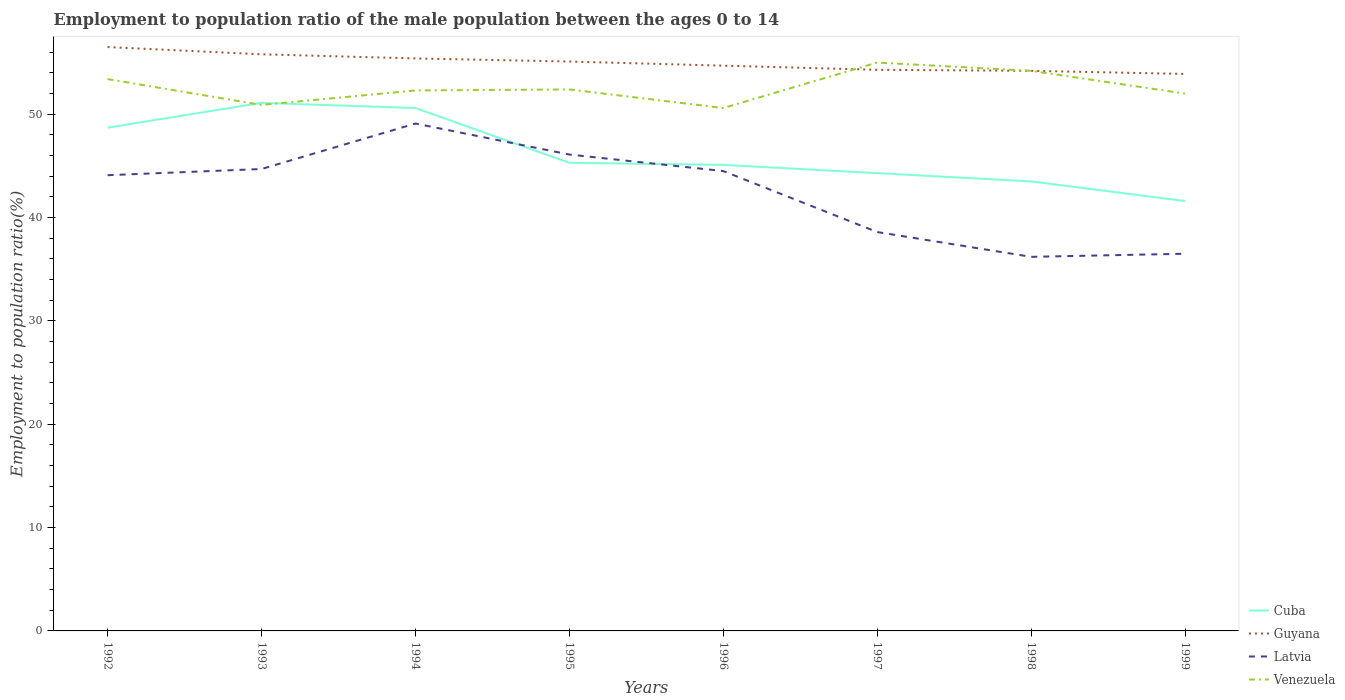How many different coloured lines are there?
Offer a terse response. 4. Is the number of lines equal to the number of legend labels?
Your response must be concise. Yes. Across all years, what is the maximum employment to population ratio in Latvia?
Provide a succinct answer. 36.2. What is the total employment to population ratio in Latvia in the graph?
Keep it short and to the point. 8.3. What is the difference between the highest and the second highest employment to population ratio in Venezuela?
Give a very brief answer. 4.4. Is the employment to population ratio in Venezuela strictly greater than the employment to population ratio in Cuba over the years?
Keep it short and to the point. No. Are the values on the major ticks of Y-axis written in scientific E-notation?
Keep it short and to the point. No. Does the graph contain any zero values?
Your response must be concise. No. How are the legend labels stacked?
Provide a short and direct response. Vertical. What is the title of the graph?
Make the answer very short. Employment to population ratio of the male population between the ages 0 to 14. What is the label or title of the X-axis?
Ensure brevity in your answer.  Years. What is the Employment to population ratio(%) of Cuba in 1992?
Offer a terse response. 48.7. What is the Employment to population ratio(%) of Guyana in 1992?
Keep it short and to the point. 56.5. What is the Employment to population ratio(%) in Latvia in 1992?
Your response must be concise. 44.1. What is the Employment to population ratio(%) in Venezuela in 1992?
Your answer should be compact. 53.4. What is the Employment to population ratio(%) in Cuba in 1993?
Provide a short and direct response. 51.1. What is the Employment to population ratio(%) of Guyana in 1993?
Your answer should be compact. 55.8. What is the Employment to population ratio(%) of Latvia in 1993?
Provide a succinct answer. 44.7. What is the Employment to population ratio(%) in Venezuela in 1993?
Make the answer very short. 50.9. What is the Employment to population ratio(%) in Cuba in 1994?
Ensure brevity in your answer.  50.6. What is the Employment to population ratio(%) in Guyana in 1994?
Ensure brevity in your answer.  55.4. What is the Employment to population ratio(%) in Latvia in 1994?
Your answer should be very brief. 49.1. What is the Employment to population ratio(%) of Venezuela in 1994?
Provide a succinct answer. 52.3. What is the Employment to population ratio(%) in Cuba in 1995?
Ensure brevity in your answer.  45.3. What is the Employment to population ratio(%) of Guyana in 1995?
Your response must be concise. 55.1. What is the Employment to population ratio(%) of Latvia in 1995?
Your answer should be very brief. 46.1. What is the Employment to population ratio(%) of Venezuela in 1995?
Make the answer very short. 52.4. What is the Employment to population ratio(%) in Cuba in 1996?
Keep it short and to the point. 45.1. What is the Employment to population ratio(%) in Guyana in 1996?
Make the answer very short. 54.7. What is the Employment to population ratio(%) of Latvia in 1996?
Keep it short and to the point. 44.5. What is the Employment to population ratio(%) of Venezuela in 1996?
Make the answer very short. 50.6. What is the Employment to population ratio(%) in Cuba in 1997?
Your answer should be very brief. 44.3. What is the Employment to population ratio(%) of Guyana in 1997?
Your answer should be compact. 54.3. What is the Employment to population ratio(%) in Latvia in 1997?
Offer a terse response. 38.6. What is the Employment to population ratio(%) of Cuba in 1998?
Make the answer very short. 43.5. What is the Employment to population ratio(%) of Guyana in 1998?
Ensure brevity in your answer.  54.2. What is the Employment to population ratio(%) in Latvia in 1998?
Offer a very short reply. 36.2. What is the Employment to population ratio(%) of Venezuela in 1998?
Make the answer very short. 54.2. What is the Employment to population ratio(%) in Cuba in 1999?
Your response must be concise. 41.6. What is the Employment to population ratio(%) in Guyana in 1999?
Your response must be concise. 53.9. What is the Employment to population ratio(%) in Latvia in 1999?
Keep it short and to the point. 36.5. Across all years, what is the maximum Employment to population ratio(%) in Cuba?
Give a very brief answer. 51.1. Across all years, what is the maximum Employment to population ratio(%) in Guyana?
Provide a succinct answer. 56.5. Across all years, what is the maximum Employment to population ratio(%) of Latvia?
Your answer should be compact. 49.1. Across all years, what is the minimum Employment to population ratio(%) in Cuba?
Provide a short and direct response. 41.6. Across all years, what is the minimum Employment to population ratio(%) of Guyana?
Your response must be concise. 53.9. Across all years, what is the minimum Employment to population ratio(%) of Latvia?
Your answer should be compact. 36.2. Across all years, what is the minimum Employment to population ratio(%) of Venezuela?
Ensure brevity in your answer.  50.6. What is the total Employment to population ratio(%) in Cuba in the graph?
Offer a very short reply. 370.2. What is the total Employment to population ratio(%) in Guyana in the graph?
Make the answer very short. 439.9. What is the total Employment to population ratio(%) in Latvia in the graph?
Provide a succinct answer. 339.8. What is the total Employment to population ratio(%) of Venezuela in the graph?
Your response must be concise. 420.8. What is the difference between the Employment to population ratio(%) of Latvia in 1992 and that in 1993?
Give a very brief answer. -0.6. What is the difference between the Employment to population ratio(%) of Cuba in 1992 and that in 1994?
Give a very brief answer. -1.9. What is the difference between the Employment to population ratio(%) in Guyana in 1992 and that in 1994?
Your answer should be compact. 1.1. What is the difference between the Employment to population ratio(%) in Latvia in 1992 and that in 1994?
Make the answer very short. -5. What is the difference between the Employment to population ratio(%) of Latvia in 1992 and that in 1995?
Your answer should be compact. -2. What is the difference between the Employment to population ratio(%) of Venezuela in 1992 and that in 1995?
Make the answer very short. 1. What is the difference between the Employment to population ratio(%) of Cuba in 1992 and that in 1996?
Your answer should be very brief. 3.6. What is the difference between the Employment to population ratio(%) of Cuba in 1992 and that in 1998?
Provide a short and direct response. 5.2. What is the difference between the Employment to population ratio(%) in Guyana in 1992 and that in 1998?
Offer a terse response. 2.3. What is the difference between the Employment to population ratio(%) in Venezuela in 1992 and that in 1998?
Ensure brevity in your answer.  -0.8. What is the difference between the Employment to population ratio(%) in Cuba in 1992 and that in 1999?
Your answer should be compact. 7.1. What is the difference between the Employment to population ratio(%) in Venezuela in 1992 and that in 1999?
Provide a short and direct response. 1.4. What is the difference between the Employment to population ratio(%) of Cuba in 1993 and that in 1994?
Your answer should be very brief. 0.5. What is the difference between the Employment to population ratio(%) of Cuba in 1993 and that in 1995?
Your answer should be compact. 5.8. What is the difference between the Employment to population ratio(%) in Latvia in 1993 and that in 1995?
Your answer should be very brief. -1.4. What is the difference between the Employment to population ratio(%) in Venezuela in 1993 and that in 1995?
Make the answer very short. -1.5. What is the difference between the Employment to population ratio(%) of Cuba in 1993 and that in 1996?
Give a very brief answer. 6. What is the difference between the Employment to population ratio(%) in Latvia in 1993 and that in 1996?
Provide a succinct answer. 0.2. What is the difference between the Employment to population ratio(%) of Cuba in 1993 and that in 1997?
Provide a succinct answer. 6.8. What is the difference between the Employment to population ratio(%) in Guyana in 1993 and that in 1998?
Ensure brevity in your answer.  1.6. What is the difference between the Employment to population ratio(%) of Latvia in 1993 and that in 1998?
Make the answer very short. 8.5. What is the difference between the Employment to population ratio(%) of Venezuela in 1993 and that in 1998?
Offer a terse response. -3.3. What is the difference between the Employment to population ratio(%) of Latvia in 1993 and that in 1999?
Offer a very short reply. 8.2. What is the difference between the Employment to population ratio(%) in Venezuela in 1993 and that in 1999?
Your response must be concise. -1.1. What is the difference between the Employment to population ratio(%) in Cuba in 1994 and that in 1995?
Offer a terse response. 5.3. What is the difference between the Employment to population ratio(%) of Guyana in 1994 and that in 1996?
Offer a very short reply. 0.7. What is the difference between the Employment to population ratio(%) in Venezuela in 1994 and that in 1996?
Provide a short and direct response. 1.7. What is the difference between the Employment to population ratio(%) of Latvia in 1994 and that in 1997?
Make the answer very short. 10.5. What is the difference between the Employment to population ratio(%) in Venezuela in 1994 and that in 1997?
Make the answer very short. -2.7. What is the difference between the Employment to population ratio(%) in Cuba in 1994 and that in 1999?
Offer a very short reply. 9. What is the difference between the Employment to population ratio(%) of Latvia in 1994 and that in 1999?
Your answer should be compact. 12.6. What is the difference between the Employment to population ratio(%) of Cuba in 1995 and that in 1996?
Offer a very short reply. 0.2. What is the difference between the Employment to population ratio(%) of Latvia in 1995 and that in 1996?
Your answer should be compact. 1.6. What is the difference between the Employment to population ratio(%) in Cuba in 1995 and that in 1997?
Your response must be concise. 1. What is the difference between the Employment to population ratio(%) in Latvia in 1995 and that in 1997?
Provide a short and direct response. 7.5. What is the difference between the Employment to population ratio(%) in Venezuela in 1995 and that in 1998?
Provide a short and direct response. -1.8. What is the difference between the Employment to population ratio(%) in Cuba in 1996 and that in 1997?
Ensure brevity in your answer.  0.8. What is the difference between the Employment to population ratio(%) of Venezuela in 1996 and that in 1997?
Your response must be concise. -4.4. What is the difference between the Employment to population ratio(%) in Cuba in 1996 and that in 1998?
Provide a succinct answer. 1.6. What is the difference between the Employment to population ratio(%) of Latvia in 1996 and that in 1998?
Ensure brevity in your answer.  8.3. What is the difference between the Employment to population ratio(%) in Guyana in 1996 and that in 1999?
Keep it short and to the point. 0.8. What is the difference between the Employment to population ratio(%) of Latvia in 1996 and that in 1999?
Provide a short and direct response. 8. What is the difference between the Employment to population ratio(%) in Venezuela in 1996 and that in 1999?
Ensure brevity in your answer.  -1.4. What is the difference between the Employment to population ratio(%) of Cuba in 1997 and that in 1998?
Give a very brief answer. 0.8. What is the difference between the Employment to population ratio(%) in Guyana in 1997 and that in 1998?
Ensure brevity in your answer.  0.1. What is the difference between the Employment to population ratio(%) of Venezuela in 1997 and that in 1998?
Provide a succinct answer. 0.8. What is the difference between the Employment to population ratio(%) in Latvia in 1997 and that in 1999?
Offer a very short reply. 2.1. What is the difference between the Employment to population ratio(%) of Guyana in 1998 and that in 1999?
Keep it short and to the point. 0.3. What is the difference between the Employment to population ratio(%) in Latvia in 1998 and that in 1999?
Offer a very short reply. -0.3. What is the difference between the Employment to population ratio(%) of Venezuela in 1998 and that in 1999?
Ensure brevity in your answer.  2.2. What is the difference between the Employment to population ratio(%) in Cuba in 1992 and the Employment to population ratio(%) in Venezuela in 1993?
Your answer should be compact. -2.2. What is the difference between the Employment to population ratio(%) in Guyana in 1992 and the Employment to population ratio(%) in Latvia in 1993?
Your answer should be very brief. 11.8. What is the difference between the Employment to population ratio(%) of Guyana in 1992 and the Employment to population ratio(%) of Venezuela in 1993?
Provide a succinct answer. 5.6. What is the difference between the Employment to population ratio(%) in Latvia in 1992 and the Employment to population ratio(%) in Venezuela in 1993?
Give a very brief answer. -6.8. What is the difference between the Employment to population ratio(%) of Cuba in 1992 and the Employment to population ratio(%) of Guyana in 1994?
Your answer should be compact. -6.7. What is the difference between the Employment to population ratio(%) in Latvia in 1992 and the Employment to population ratio(%) in Venezuela in 1994?
Ensure brevity in your answer.  -8.2. What is the difference between the Employment to population ratio(%) in Cuba in 1992 and the Employment to population ratio(%) in Guyana in 1995?
Offer a terse response. -6.4. What is the difference between the Employment to population ratio(%) in Cuba in 1992 and the Employment to population ratio(%) in Latvia in 1995?
Offer a very short reply. 2.6. What is the difference between the Employment to population ratio(%) in Cuba in 1992 and the Employment to population ratio(%) in Venezuela in 1995?
Your answer should be compact. -3.7. What is the difference between the Employment to population ratio(%) in Guyana in 1992 and the Employment to population ratio(%) in Latvia in 1995?
Keep it short and to the point. 10.4. What is the difference between the Employment to population ratio(%) in Guyana in 1992 and the Employment to population ratio(%) in Venezuela in 1995?
Provide a short and direct response. 4.1. What is the difference between the Employment to population ratio(%) in Latvia in 1992 and the Employment to population ratio(%) in Venezuela in 1995?
Provide a short and direct response. -8.3. What is the difference between the Employment to population ratio(%) in Cuba in 1992 and the Employment to population ratio(%) in Venezuela in 1996?
Ensure brevity in your answer.  -1.9. What is the difference between the Employment to population ratio(%) of Guyana in 1992 and the Employment to population ratio(%) of Latvia in 1996?
Your answer should be compact. 12. What is the difference between the Employment to population ratio(%) of Guyana in 1992 and the Employment to population ratio(%) of Venezuela in 1996?
Provide a succinct answer. 5.9. What is the difference between the Employment to population ratio(%) of Latvia in 1992 and the Employment to population ratio(%) of Venezuela in 1996?
Offer a terse response. -6.5. What is the difference between the Employment to population ratio(%) of Cuba in 1992 and the Employment to population ratio(%) of Latvia in 1997?
Provide a succinct answer. 10.1. What is the difference between the Employment to population ratio(%) in Cuba in 1992 and the Employment to population ratio(%) in Venezuela in 1997?
Offer a very short reply. -6.3. What is the difference between the Employment to population ratio(%) of Latvia in 1992 and the Employment to population ratio(%) of Venezuela in 1997?
Your answer should be compact. -10.9. What is the difference between the Employment to population ratio(%) of Cuba in 1992 and the Employment to population ratio(%) of Guyana in 1998?
Make the answer very short. -5.5. What is the difference between the Employment to population ratio(%) of Guyana in 1992 and the Employment to population ratio(%) of Latvia in 1998?
Provide a succinct answer. 20.3. What is the difference between the Employment to population ratio(%) of Guyana in 1992 and the Employment to population ratio(%) of Venezuela in 1998?
Offer a very short reply. 2.3. What is the difference between the Employment to population ratio(%) in Latvia in 1992 and the Employment to population ratio(%) in Venezuela in 1998?
Ensure brevity in your answer.  -10.1. What is the difference between the Employment to population ratio(%) of Cuba in 1992 and the Employment to population ratio(%) of Guyana in 1999?
Your answer should be compact. -5.2. What is the difference between the Employment to population ratio(%) in Cuba in 1992 and the Employment to population ratio(%) in Latvia in 1999?
Ensure brevity in your answer.  12.2. What is the difference between the Employment to population ratio(%) of Cuba in 1992 and the Employment to population ratio(%) of Venezuela in 1999?
Provide a short and direct response. -3.3. What is the difference between the Employment to population ratio(%) in Latvia in 1992 and the Employment to population ratio(%) in Venezuela in 1999?
Make the answer very short. -7.9. What is the difference between the Employment to population ratio(%) in Guyana in 1993 and the Employment to population ratio(%) in Latvia in 1994?
Your answer should be compact. 6.7. What is the difference between the Employment to population ratio(%) in Guyana in 1993 and the Employment to population ratio(%) in Venezuela in 1994?
Provide a short and direct response. 3.5. What is the difference between the Employment to population ratio(%) of Cuba in 1993 and the Employment to population ratio(%) of Guyana in 1995?
Keep it short and to the point. -4. What is the difference between the Employment to population ratio(%) of Cuba in 1993 and the Employment to population ratio(%) of Latvia in 1995?
Provide a short and direct response. 5. What is the difference between the Employment to population ratio(%) of Guyana in 1993 and the Employment to population ratio(%) of Latvia in 1995?
Provide a succinct answer. 9.7. What is the difference between the Employment to population ratio(%) in Latvia in 1993 and the Employment to population ratio(%) in Venezuela in 1995?
Ensure brevity in your answer.  -7.7. What is the difference between the Employment to population ratio(%) of Cuba in 1993 and the Employment to population ratio(%) of Venezuela in 1996?
Your answer should be compact. 0.5. What is the difference between the Employment to population ratio(%) in Guyana in 1993 and the Employment to population ratio(%) in Latvia in 1996?
Offer a terse response. 11.3. What is the difference between the Employment to population ratio(%) in Guyana in 1993 and the Employment to population ratio(%) in Venezuela in 1996?
Make the answer very short. 5.2. What is the difference between the Employment to population ratio(%) of Cuba in 1993 and the Employment to population ratio(%) of Guyana in 1997?
Ensure brevity in your answer.  -3.2. What is the difference between the Employment to population ratio(%) in Cuba in 1993 and the Employment to population ratio(%) in Latvia in 1997?
Your response must be concise. 12.5. What is the difference between the Employment to population ratio(%) in Latvia in 1993 and the Employment to population ratio(%) in Venezuela in 1997?
Your answer should be very brief. -10.3. What is the difference between the Employment to population ratio(%) in Guyana in 1993 and the Employment to population ratio(%) in Latvia in 1998?
Provide a short and direct response. 19.6. What is the difference between the Employment to population ratio(%) of Latvia in 1993 and the Employment to population ratio(%) of Venezuela in 1998?
Provide a short and direct response. -9.5. What is the difference between the Employment to population ratio(%) of Cuba in 1993 and the Employment to population ratio(%) of Guyana in 1999?
Your answer should be compact. -2.8. What is the difference between the Employment to population ratio(%) in Guyana in 1993 and the Employment to population ratio(%) in Latvia in 1999?
Provide a short and direct response. 19.3. What is the difference between the Employment to population ratio(%) of Guyana in 1993 and the Employment to population ratio(%) of Venezuela in 1999?
Keep it short and to the point. 3.8. What is the difference between the Employment to population ratio(%) of Latvia in 1993 and the Employment to population ratio(%) of Venezuela in 1999?
Give a very brief answer. -7.3. What is the difference between the Employment to population ratio(%) in Cuba in 1994 and the Employment to population ratio(%) in Guyana in 1995?
Provide a short and direct response. -4.5. What is the difference between the Employment to population ratio(%) of Cuba in 1994 and the Employment to population ratio(%) of Latvia in 1995?
Provide a short and direct response. 4.5. What is the difference between the Employment to population ratio(%) in Cuba in 1994 and the Employment to population ratio(%) in Venezuela in 1995?
Ensure brevity in your answer.  -1.8. What is the difference between the Employment to population ratio(%) of Guyana in 1994 and the Employment to population ratio(%) of Venezuela in 1995?
Provide a succinct answer. 3. What is the difference between the Employment to population ratio(%) in Guyana in 1994 and the Employment to population ratio(%) in Latvia in 1996?
Offer a very short reply. 10.9. What is the difference between the Employment to population ratio(%) of Cuba in 1994 and the Employment to population ratio(%) of Latvia in 1997?
Give a very brief answer. 12. What is the difference between the Employment to population ratio(%) in Guyana in 1994 and the Employment to population ratio(%) in Latvia in 1997?
Give a very brief answer. 16.8. What is the difference between the Employment to population ratio(%) of Latvia in 1994 and the Employment to population ratio(%) of Venezuela in 1997?
Offer a very short reply. -5.9. What is the difference between the Employment to population ratio(%) of Cuba in 1994 and the Employment to population ratio(%) of Guyana in 1998?
Your answer should be compact. -3.6. What is the difference between the Employment to population ratio(%) of Cuba in 1994 and the Employment to population ratio(%) of Venezuela in 1998?
Provide a short and direct response. -3.6. What is the difference between the Employment to population ratio(%) in Guyana in 1994 and the Employment to population ratio(%) in Venezuela in 1998?
Offer a terse response. 1.2. What is the difference between the Employment to population ratio(%) in Cuba in 1994 and the Employment to population ratio(%) in Latvia in 1999?
Your answer should be very brief. 14.1. What is the difference between the Employment to population ratio(%) in Latvia in 1994 and the Employment to population ratio(%) in Venezuela in 1999?
Your answer should be compact. -2.9. What is the difference between the Employment to population ratio(%) of Guyana in 1995 and the Employment to population ratio(%) of Latvia in 1997?
Make the answer very short. 16.5. What is the difference between the Employment to population ratio(%) in Cuba in 1995 and the Employment to population ratio(%) in Latvia in 1998?
Ensure brevity in your answer.  9.1. What is the difference between the Employment to population ratio(%) of Guyana in 1995 and the Employment to population ratio(%) of Latvia in 1998?
Offer a terse response. 18.9. What is the difference between the Employment to population ratio(%) of Guyana in 1995 and the Employment to population ratio(%) of Venezuela in 1998?
Your response must be concise. 0.9. What is the difference between the Employment to population ratio(%) in Cuba in 1995 and the Employment to population ratio(%) in Latvia in 1999?
Give a very brief answer. 8.8. What is the difference between the Employment to population ratio(%) of Guyana in 1995 and the Employment to population ratio(%) of Latvia in 1999?
Your answer should be compact. 18.6. What is the difference between the Employment to population ratio(%) in Latvia in 1995 and the Employment to population ratio(%) in Venezuela in 1999?
Offer a terse response. -5.9. What is the difference between the Employment to population ratio(%) in Cuba in 1996 and the Employment to population ratio(%) in Guyana in 1997?
Your response must be concise. -9.2. What is the difference between the Employment to population ratio(%) in Cuba in 1996 and the Employment to population ratio(%) in Venezuela in 1997?
Ensure brevity in your answer.  -9.9. What is the difference between the Employment to population ratio(%) in Latvia in 1996 and the Employment to population ratio(%) in Venezuela in 1997?
Your answer should be very brief. -10.5. What is the difference between the Employment to population ratio(%) of Cuba in 1996 and the Employment to population ratio(%) of Guyana in 1998?
Offer a terse response. -9.1. What is the difference between the Employment to population ratio(%) in Cuba in 1996 and the Employment to population ratio(%) in Venezuela in 1998?
Offer a terse response. -9.1. What is the difference between the Employment to population ratio(%) of Guyana in 1996 and the Employment to population ratio(%) of Latvia in 1998?
Keep it short and to the point. 18.5. What is the difference between the Employment to population ratio(%) in Latvia in 1996 and the Employment to population ratio(%) in Venezuela in 1998?
Offer a very short reply. -9.7. What is the difference between the Employment to population ratio(%) of Cuba in 1996 and the Employment to population ratio(%) of Guyana in 1999?
Your answer should be compact. -8.8. What is the difference between the Employment to population ratio(%) of Cuba in 1996 and the Employment to population ratio(%) of Venezuela in 1999?
Give a very brief answer. -6.9. What is the difference between the Employment to population ratio(%) of Latvia in 1996 and the Employment to population ratio(%) of Venezuela in 1999?
Give a very brief answer. -7.5. What is the difference between the Employment to population ratio(%) in Cuba in 1997 and the Employment to population ratio(%) in Guyana in 1998?
Your answer should be compact. -9.9. What is the difference between the Employment to population ratio(%) of Cuba in 1997 and the Employment to population ratio(%) of Latvia in 1998?
Your answer should be very brief. 8.1. What is the difference between the Employment to population ratio(%) of Guyana in 1997 and the Employment to population ratio(%) of Venezuela in 1998?
Your answer should be compact. 0.1. What is the difference between the Employment to population ratio(%) of Latvia in 1997 and the Employment to population ratio(%) of Venezuela in 1998?
Provide a short and direct response. -15.6. What is the difference between the Employment to population ratio(%) of Cuba in 1997 and the Employment to population ratio(%) of Venezuela in 1999?
Make the answer very short. -7.7. What is the difference between the Employment to population ratio(%) in Guyana in 1997 and the Employment to population ratio(%) in Latvia in 1999?
Your answer should be compact. 17.8. What is the difference between the Employment to population ratio(%) of Guyana in 1998 and the Employment to population ratio(%) of Venezuela in 1999?
Your response must be concise. 2.2. What is the difference between the Employment to population ratio(%) in Latvia in 1998 and the Employment to population ratio(%) in Venezuela in 1999?
Your answer should be compact. -15.8. What is the average Employment to population ratio(%) of Cuba per year?
Provide a short and direct response. 46.27. What is the average Employment to population ratio(%) of Guyana per year?
Make the answer very short. 54.99. What is the average Employment to population ratio(%) in Latvia per year?
Make the answer very short. 42.48. What is the average Employment to population ratio(%) of Venezuela per year?
Keep it short and to the point. 52.6. In the year 1992, what is the difference between the Employment to population ratio(%) of Guyana and Employment to population ratio(%) of Latvia?
Your response must be concise. 12.4. In the year 1993, what is the difference between the Employment to population ratio(%) in Cuba and Employment to population ratio(%) in Guyana?
Offer a very short reply. -4.7. In the year 1993, what is the difference between the Employment to population ratio(%) in Cuba and Employment to population ratio(%) in Latvia?
Your answer should be compact. 6.4. In the year 1993, what is the difference between the Employment to population ratio(%) of Guyana and Employment to population ratio(%) of Latvia?
Your answer should be very brief. 11.1. In the year 1993, what is the difference between the Employment to population ratio(%) of Guyana and Employment to population ratio(%) of Venezuela?
Your answer should be very brief. 4.9. In the year 1993, what is the difference between the Employment to population ratio(%) in Latvia and Employment to population ratio(%) in Venezuela?
Offer a very short reply. -6.2. In the year 1994, what is the difference between the Employment to population ratio(%) in Cuba and Employment to population ratio(%) in Guyana?
Your response must be concise. -4.8. In the year 1994, what is the difference between the Employment to population ratio(%) of Cuba and Employment to population ratio(%) of Latvia?
Provide a short and direct response. 1.5. In the year 1994, what is the difference between the Employment to population ratio(%) of Guyana and Employment to population ratio(%) of Venezuela?
Your answer should be compact. 3.1. In the year 1994, what is the difference between the Employment to population ratio(%) in Latvia and Employment to population ratio(%) in Venezuela?
Offer a terse response. -3.2. In the year 1995, what is the difference between the Employment to population ratio(%) of Cuba and Employment to population ratio(%) of Venezuela?
Your answer should be very brief. -7.1. In the year 1996, what is the difference between the Employment to population ratio(%) of Cuba and Employment to population ratio(%) of Guyana?
Provide a short and direct response. -9.6. In the year 1996, what is the difference between the Employment to population ratio(%) of Cuba and Employment to population ratio(%) of Venezuela?
Your answer should be very brief. -5.5. In the year 1996, what is the difference between the Employment to population ratio(%) of Guyana and Employment to population ratio(%) of Venezuela?
Make the answer very short. 4.1. In the year 1996, what is the difference between the Employment to population ratio(%) in Latvia and Employment to population ratio(%) in Venezuela?
Keep it short and to the point. -6.1. In the year 1997, what is the difference between the Employment to population ratio(%) in Cuba and Employment to population ratio(%) in Guyana?
Offer a terse response. -10. In the year 1997, what is the difference between the Employment to population ratio(%) in Cuba and Employment to population ratio(%) in Latvia?
Your response must be concise. 5.7. In the year 1997, what is the difference between the Employment to population ratio(%) of Cuba and Employment to population ratio(%) of Venezuela?
Offer a terse response. -10.7. In the year 1997, what is the difference between the Employment to population ratio(%) in Guyana and Employment to population ratio(%) in Venezuela?
Provide a short and direct response. -0.7. In the year 1997, what is the difference between the Employment to population ratio(%) in Latvia and Employment to population ratio(%) in Venezuela?
Offer a terse response. -16.4. In the year 1998, what is the difference between the Employment to population ratio(%) of Cuba and Employment to population ratio(%) of Guyana?
Ensure brevity in your answer.  -10.7. In the year 1998, what is the difference between the Employment to population ratio(%) in Cuba and Employment to population ratio(%) in Latvia?
Give a very brief answer. 7.3. In the year 1998, what is the difference between the Employment to population ratio(%) of Cuba and Employment to population ratio(%) of Venezuela?
Provide a succinct answer. -10.7. In the year 1998, what is the difference between the Employment to population ratio(%) of Guyana and Employment to population ratio(%) of Venezuela?
Ensure brevity in your answer.  0. In the year 1999, what is the difference between the Employment to population ratio(%) in Cuba and Employment to population ratio(%) in Guyana?
Your response must be concise. -12.3. In the year 1999, what is the difference between the Employment to population ratio(%) in Latvia and Employment to population ratio(%) in Venezuela?
Your response must be concise. -15.5. What is the ratio of the Employment to population ratio(%) in Cuba in 1992 to that in 1993?
Ensure brevity in your answer.  0.95. What is the ratio of the Employment to population ratio(%) of Guyana in 1992 to that in 1993?
Provide a short and direct response. 1.01. What is the ratio of the Employment to population ratio(%) of Latvia in 1992 to that in 1993?
Your answer should be compact. 0.99. What is the ratio of the Employment to population ratio(%) of Venezuela in 1992 to that in 1993?
Provide a short and direct response. 1.05. What is the ratio of the Employment to population ratio(%) in Cuba in 1992 to that in 1994?
Your response must be concise. 0.96. What is the ratio of the Employment to population ratio(%) in Guyana in 1992 to that in 1994?
Provide a succinct answer. 1.02. What is the ratio of the Employment to population ratio(%) of Latvia in 1992 to that in 1994?
Keep it short and to the point. 0.9. What is the ratio of the Employment to population ratio(%) of Venezuela in 1992 to that in 1994?
Give a very brief answer. 1.02. What is the ratio of the Employment to population ratio(%) of Cuba in 1992 to that in 1995?
Provide a short and direct response. 1.08. What is the ratio of the Employment to population ratio(%) in Guyana in 1992 to that in 1995?
Your answer should be compact. 1.03. What is the ratio of the Employment to population ratio(%) in Latvia in 1992 to that in 1995?
Your answer should be very brief. 0.96. What is the ratio of the Employment to population ratio(%) in Venezuela in 1992 to that in 1995?
Keep it short and to the point. 1.02. What is the ratio of the Employment to population ratio(%) of Cuba in 1992 to that in 1996?
Offer a very short reply. 1.08. What is the ratio of the Employment to population ratio(%) of Guyana in 1992 to that in 1996?
Keep it short and to the point. 1.03. What is the ratio of the Employment to population ratio(%) of Venezuela in 1992 to that in 1996?
Your response must be concise. 1.06. What is the ratio of the Employment to population ratio(%) in Cuba in 1992 to that in 1997?
Your answer should be very brief. 1.1. What is the ratio of the Employment to population ratio(%) of Guyana in 1992 to that in 1997?
Offer a very short reply. 1.04. What is the ratio of the Employment to population ratio(%) in Latvia in 1992 to that in 1997?
Your answer should be compact. 1.14. What is the ratio of the Employment to population ratio(%) in Venezuela in 1992 to that in 1997?
Provide a succinct answer. 0.97. What is the ratio of the Employment to population ratio(%) in Cuba in 1992 to that in 1998?
Provide a short and direct response. 1.12. What is the ratio of the Employment to population ratio(%) of Guyana in 1992 to that in 1998?
Your answer should be compact. 1.04. What is the ratio of the Employment to population ratio(%) in Latvia in 1992 to that in 1998?
Ensure brevity in your answer.  1.22. What is the ratio of the Employment to population ratio(%) in Venezuela in 1992 to that in 1998?
Provide a succinct answer. 0.99. What is the ratio of the Employment to population ratio(%) of Cuba in 1992 to that in 1999?
Provide a succinct answer. 1.17. What is the ratio of the Employment to population ratio(%) in Guyana in 1992 to that in 1999?
Your response must be concise. 1.05. What is the ratio of the Employment to population ratio(%) in Latvia in 1992 to that in 1999?
Ensure brevity in your answer.  1.21. What is the ratio of the Employment to population ratio(%) of Venezuela in 1992 to that in 1999?
Offer a very short reply. 1.03. What is the ratio of the Employment to population ratio(%) of Cuba in 1993 to that in 1994?
Keep it short and to the point. 1.01. What is the ratio of the Employment to population ratio(%) in Latvia in 1993 to that in 1994?
Keep it short and to the point. 0.91. What is the ratio of the Employment to population ratio(%) in Venezuela in 1993 to that in 1994?
Provide a short and direct response. 0.97. What is the ratio of the Employment to population ratio(%) of Cuba in 1993 to that in 1995?
Provide a short and direct response. 1.13. What is the ratio of the Employment to population ratio(%) in Guyana in 1993 to that in 1995?
Your answer should be very brief. 1.01. What is the ratio of the Employment to population ratio(%) of Latvia in 1993 to that in 1995?
Offer a very short reply. 0.97. What is the ratio of the Employment to population ratio(%) in Venezuela in 1993 to that in 1995?
Provide a short and direct response. 0.97. What is the ratio of the Employment to population ratio(%) in Cuba in 1993 to that in 1996?
Keep it short and to the point. 1.13. What is the ratio of the Employment to population ratio(%) of Guyana in 1993 to that in 1996?
Your response must be concise. 1.02. What is the ratio of the Employment to population ratio(%) in Latvia in 1993 to that in 1996?
Your answer should be very brief. 1. What is the ratio of the Employment to population ratio(%) of Venezuela in 1993 to that in 1996?
Provide a short and direct response. 1.01. What is the ratio of the Employment to population ratio(%) in Cuba in 1993 to that in 1997?
Make the answer very short. 1.15. What is the ratio of the Employment to population ratio(%) of Guyana in 1993 to that in 1997?
Provide a short and direct response. 1.03. What is the ratio of the Employment to population ratio(%) of Latvia in 1993 to that in 1997?
Make the answer very short. 1.16. What is the ratio of the Employment to population ratio(%) in Venezuela in 1993 to that in 1997?
Give a very brief answer. 0.93. What is the ratio of the Employment to population ratio(%) in Cuba in 1993 to that in 1998?
Your answer should be very brief. 1.17. What is the ratio of the Employment to population ratio(%) of Guyana in 1993 to that in 1998?
Your answer should be very brief. 1.03. What is the ratio of the Employment to population ratio(%) in Latvia in 1993 to that in 1998?
Offer a terse response. 1.23. What is the ratio of the Employment to population ratio(%) in Venezuela in 1993 to that in 1998?
Ensure brevity in your answer.  0.94. What is the ratio of the Employment to population ratio(%) in Cuba in 1993 to that in 1999?
Provide a short and direct response. 1.23. What is the ratio of the Employment to population ratio(%) in Guyana in 1993 to that in 1999?
Your answer should be very brief. 1.04. What is the ratio of the Employment to population ratio(%) of Latvia in 1993 to that in 1999?
Your response must be concise. 1.22. What is the ratio of the Employment to population ratio(%) in Venezuela in 1993 to that in 1999?
Ensure brevity in your answer.  0.98. What is the ratio of the Employment to population ratio(%) of Cuba in 1994 to that in 1995?
Offer a terse response. 1.12. What is the ratio of the Employment to population ratio(%) in Guyana in 1994 to that in 1995?
Provide a succinct answer. 1.01. What is the ratio of the Employment to population ratio(%) of Latvia in 1994 to that in 1995?
Your response must be concise. 1.07. What is the ratio of the Employment to population ratio(%) in Venezuela in 1994 to that in 1995?
Your answer should be very brief. 1. What is the ratio of the Employment to population ratio(%) of Cuba in 1994 to that in 1996?
Make the answer very short. 1.12. What is the ratio of the Employment to population ratio(%) of Guyana in 1994 to that in 1996?
Provide a succinct answer. 1.01. What is the ratio of the Employment to population ratio(%) of Latvia in 1994 to that in 1996?
Offer a very short reply. 1.1. What is the ratio of the Employment to population ratio(%) in Venezuela in 1994 to that in 1996?
Provide a short and direct response. 1.03. What is the ratio of the Employment to population ratio(%) in Cuba in 1994 to that in 1997?
Offer a terse response. 1.14. What is the ratio of the Employment to population ratio(%) of Guyana in 1994 to that in 1997?
Provide a short and direct response. 1.02. What is the ratio of the Employment to population ratio(%) in Latvia in 1994 to that in 1997?
Your answer should be compact. 1.27. What is the ratio of the Employment to population ratio(%) in Venezuela in 1994 to that in 1997?
Offer a very short reply. 0.95. What is the ratio of the Employment to population ratio(%) of Cuba in 1994 to that in 1998?
Make the answer very short. 1.16. What is the ratio of the Employment to population ratio(%) of Guyana in 1994 to that in 1998?
Provide a succinct answer. 1.02. What is the ratio of the Employment to population ratio(%) of Latvia in 1994 to that in 1998?
Offer a very short reply. 1.36. What is the ratio of the Employment to population ratio(%) in Venezuela in 1994 to that in 1998?
Provide a short and direct response. 0.96. What is the ratio of the Employment to population ratio(%) in Cuba in 1994 to that in 1999?
Offer a very short reply. 1.22. What is the ratio of the Employment to population ratio(%) of Guyana in 1994 to that in 1999?
Provide a short and direct response. 1.03. What is the ratio of the Employment to population ratio(%) of Latvia in 1994 to that in 1999?
Keep it short and to the point. 1.35. What is the ratio of the Employment to population ratio(%) of Venezuela in 1994 to that in 1999?
Your answer should be very brief. 1.01. What is the ratio of the Employment to population ratio(%) of Cuba in 1995 to that in 1996?
Your answer should be very brief. 1. What is the ratio of the Employment to population ratio(%) of Guyana in 1995 to that in 1996?
Give a very brief answer. 1.01. What is the ratio of the Employment to population ratio(%) in Latvia in 1995 to that in 1996?
Give a very brief answer. 1.04. What is the ratio of the Employment to population ratio(%) in Venezuela in 1995 to that in 1996?
Make the answer very short. 1.04. What is the ratio of the Employment to population ratio(%) of Cuba in 1995 to that in 1997?
Provide a succinct answer. 1.02. What is the ratio of the Employment to population ratio(%) of Guyana in 1995 to that in 1997?
Your answer should be very brief. 1.01. What is the ratio of the Employment to population ratio(%) of Latvia in 1995 to that in 1997?
Provide a succinct answer. 1.19. What is the ratio of the Employment to population ratio(%) of Venezuela in 1995 to that in 1997?
Your response must be concise. 0.95. What is the ratio of the Employment to population ratio(%) in Cuba in 1995 to that in 1998?
Offer a terse response. 1.04. What is the ratio of the Employment to population ratio(%) in Guyana in 1995 to that in 1998?
Your response must be concise. 1.02. What is the ratio of the Employment to population ratio(%) of Latvia in 1995 to that in 1998?
Your answer should be very brief. 1.27. What is the ratio of the Employment to population ratio(%) of Venezuela in 1995 to that in 1998?
Offer a very short reply. 0.97. What is the ratio of the Employment to population ratio(%) of Cuba in 1995 to that in 1999?
Make the answer very short. 1.09. What is the ratio of the Employment to population ratio(%) in Guyana in 1995 to that in 1999?
Ensure brevity in your answer.  1.02. What is the ratio of the Employment to population ratio(%) of Latvia in 1995 to that in 1999?
Offer a terse response. 1.26. What is the ratio of the Employment to population ratio(%) of Venezuela in 1995 to that in 1999?
Your answer should be compact. 1.01. What is the ratio of the Employment to population ratio(%) in Cuba in 1996 to that in 1997?
Offer a very short reply. 1.02. What is the ratio of the Employment to population ratio(%) in Guyana in 1996 to that in 1997?
Offer a terse response. 1.01. What is the ratio of the Employment to population ratio(%) in Latvia in 1996 to that in 1997?
Offer a terse response. 1.15. What is the ratio of the Employment to population ratio(%) of Cuba in 1996 to that in 1998?
Your answer should be compact. 1.04. What is the ratio of the Employment to population ratio(%) in Guyana in 1996 to that in 1998?
Ensure brevity in your answer.  1.01. What is the ratio of the Employment to population ratio(%) of Latvia in 1996 to that in 1998?
Your response must be concise. 1.23. What is the ratio of the Employment to population ratio(%) of Venezuela in 1996 to that in 1998?
Your response must be concise. 0.93. What is the ratio of the Employment to population ratio(%) of Cuba in 1996 to that in 1999?
Keep it short and to the point. 1.08. What is the ratio of the Employment to population ratio(%) of Guyana in 1996 to that in 1999?
Offer a very short reply. 1.01. What is the ratio of the Employment to population ratio(%) of Latvia in 1996 to that in 1999?
Offer a terse response. 1.22. What is the ratio of the Employment to population ratio(%) of Venezuela in 1996 to that in 1999?
Offer a very short reply. 0.97. What is the ratio of the Employment to population ratio(%) of Cuba in 1997 to that in 1998?
Offer a very short reply. 1.02. What is the ratio of the Employment to population ratio(%) of Latvia in 1997 to that in 1998?
Offer a terse response. 1.07. What is the ratio of the Employment to population ratio(%) in Venezuela in 1997 to that in 1998?
Ensure brevity in your answer.  1.01. What is the ratio of the Employment to population ratio(%) in Cuba in 1997 to that in 1999?
Offer a terse response. 1.06. What is the ratio of the Employment to population ratio(%) in Guyana in 1997 to that in 1999?
Make the answer very short. 1.01. What is the ratio of the Employment to population ratio(%) of Latvia in 1997 to that in 1999?
Make the answer very short. 1.06. What is the ratio of the Employment to population ratio(%) in Venezuela in 1997 to that in 1999?
Offer a terse response. 1.06. What is the ratio of the Employment to population ratio(%) in Cuba in 1998 to that in 1999?
Make the answer very short. 1.05. What is the ratio of the Employment to population ratio(%) of Guyana in 1998 to that in 1999?
Make the answer very short. 1.01. What is the ratio of the Employment to population ratio(%) in Latvia in 1998 to that in 1999?
Provide a short and direct response. 0.99. What is the ratio of the Employment to population ratio(%) in Venezuela in 1998 to that in 1999?
Your response must be concise. 1.04. What is the difference between the highest and the second highest Employment to population ratio(%) of Cuba?
Keep it short and to the point. 0.5. What is the difference between the highest and the second highest Employment to population ratio(%) of Guyana?
Provide a short and direct response. 0.7. What is the difference between the highest and the second highest Employment to population ratio(%) in Venezuela?
Your answer should be compact. 0.8. What is the difference between the highest and the lowest Employment to population ratio(%) in Cuba?
Offer a very short reply. 9.5. What is the difference between the highest and the lowest Employment to population ratio(%) of Guyana?
Provide a succinct answer. 2.6. What is the difference between the highest and the lowest Employment to population ratio(%) of Venezuela?
Your answer should be compact. 4.4. 